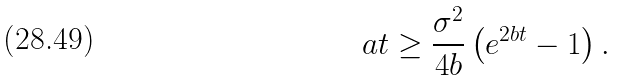<formula> <loc_0><loc_0><loc_500><loc_500>a t \geq \frac { \sigma ^ { 2 } } { 4 b } \left ( e ^ { 2 b t } - 1 \right ) .</formula> 